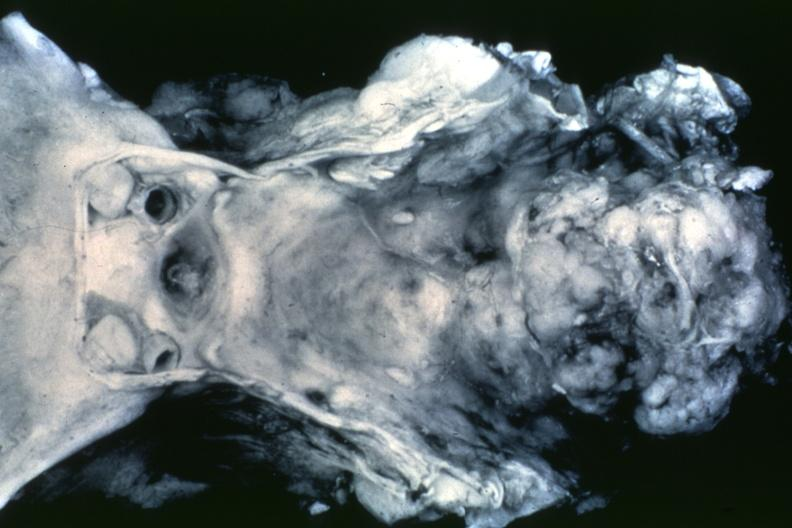what is present?
Answer the question using a single word or phrase. Bone 